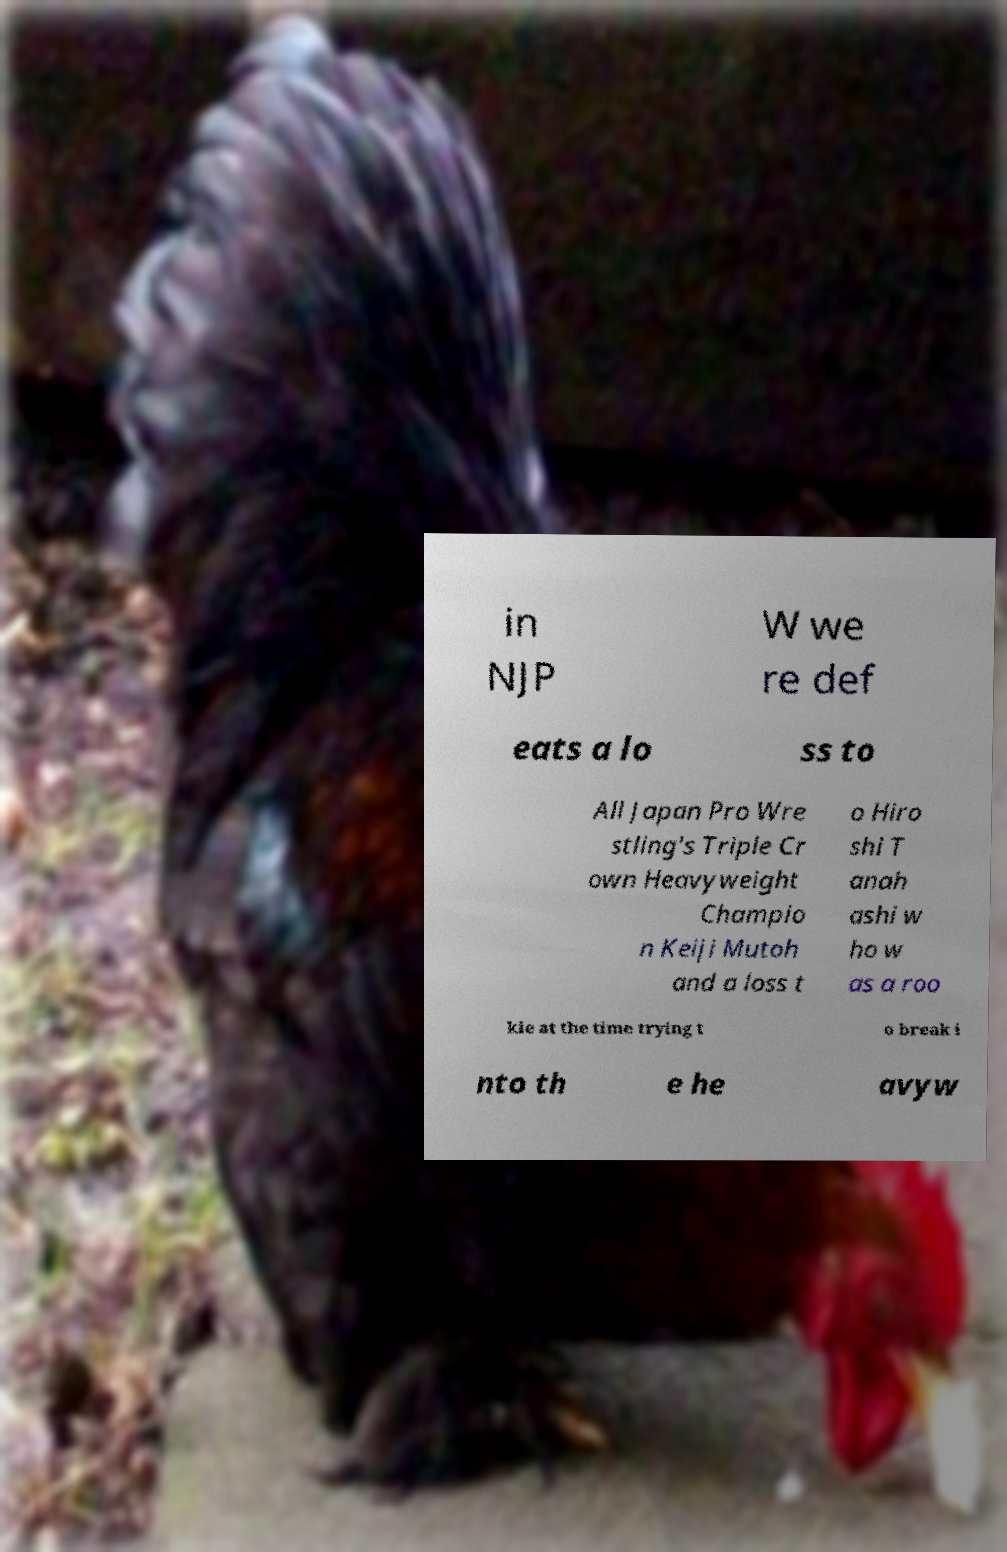Please identify and transcribe the text found in this image. in NJP W we re def eats a lo ss to All Japan Pro Wre stling's Triple Cr own Heavyweight Champio n Keiji Mutoh and a loss t o Hiro shi T anah ashi w ho w as a roo kie at the time trying t o break i nto th e he avyw 